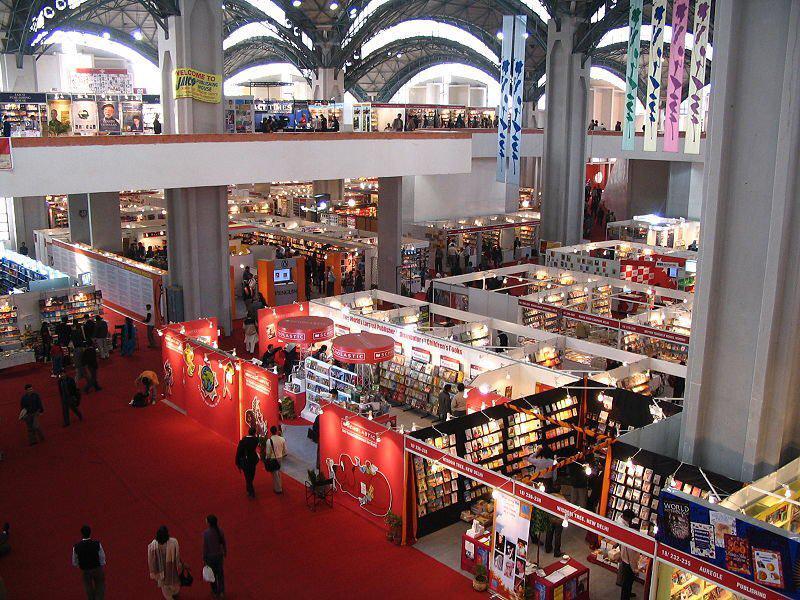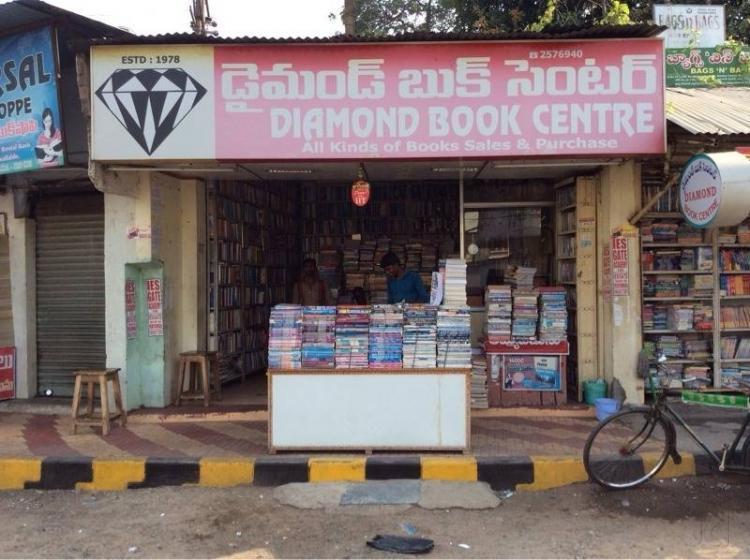The first image is the image on the left, the second image is the image on the right. Considering the images on both sides, is "There are more than half a dozen people standing around in the image on the left." valid? Answer yes or no. Yes. 